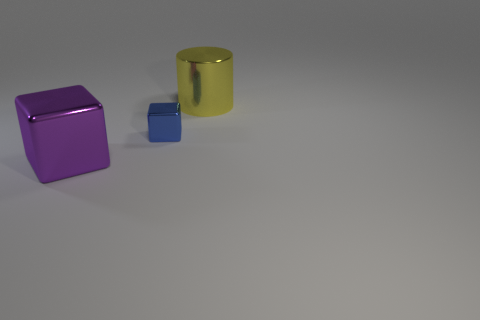Are there fewer small blue cubes right of the small block than big purple metal blocks behind the big block? Based on the image provided, it's not possible to confirm the presence of other cubes or blocks that are outside of the view. From what can be seen, there is one small blue cube to the right of a small purple block, and no additional purple metal blocks visible behind the larger yellow cylindrical block. Therefore, to be precise, there are not fewer small blue cubes right of the small block than big purple metal blocks behind the big block, because there are no big purple metal blocks behind the big block within our field of view. 